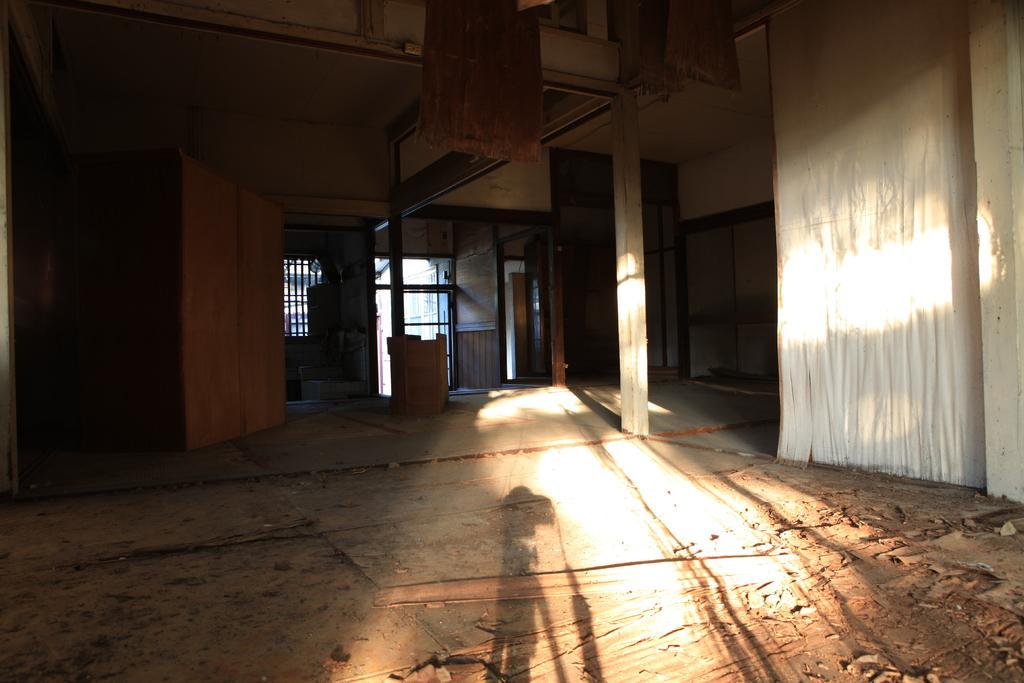Describe this image in one or two sentences. In this image we can see saw dust on the floor, doors and windows. 